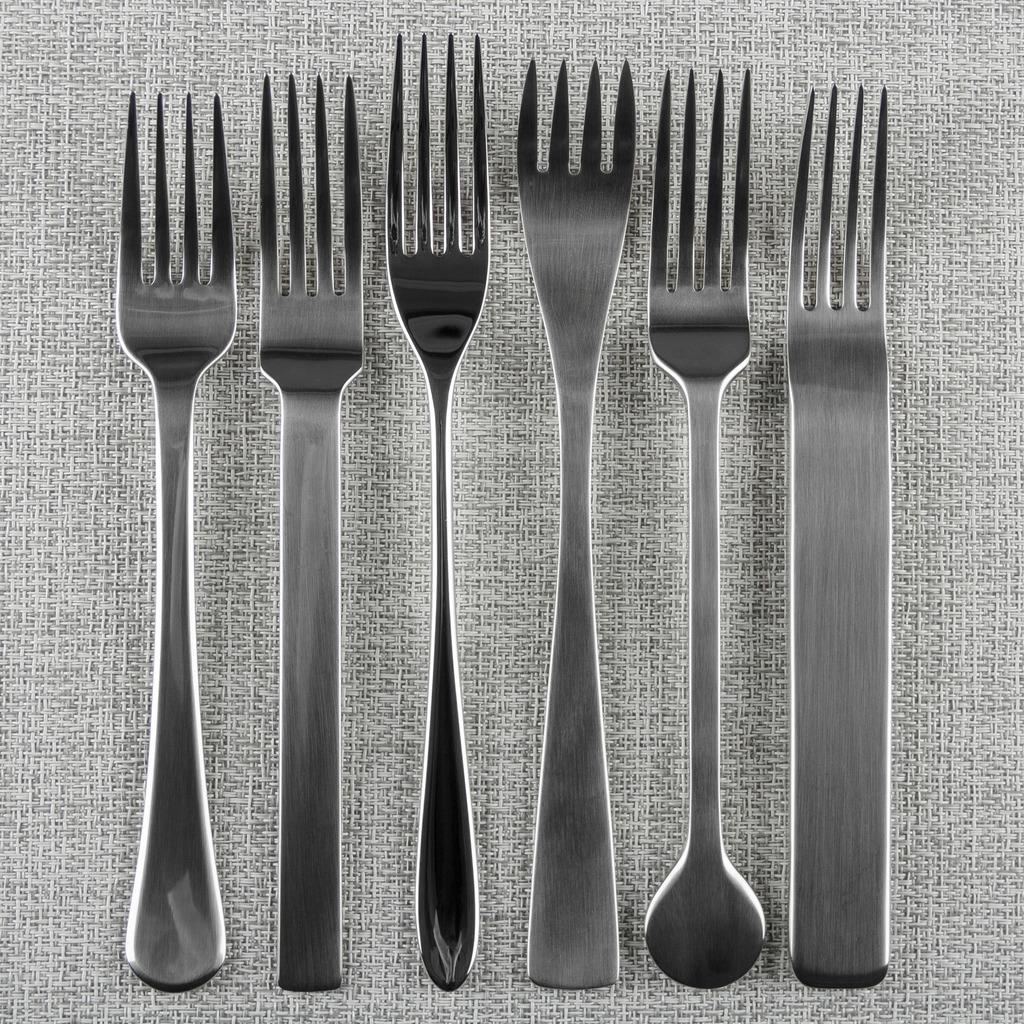What type of utensils can be seen in the image? There are different kinds of forks in the image. Where are the forks placed in the image? The forks are kept on a surface. What type of hammer is being used to dig into the earth in the image? There is no hammer or digging activity present in the image; it only features different kinds of forks. 